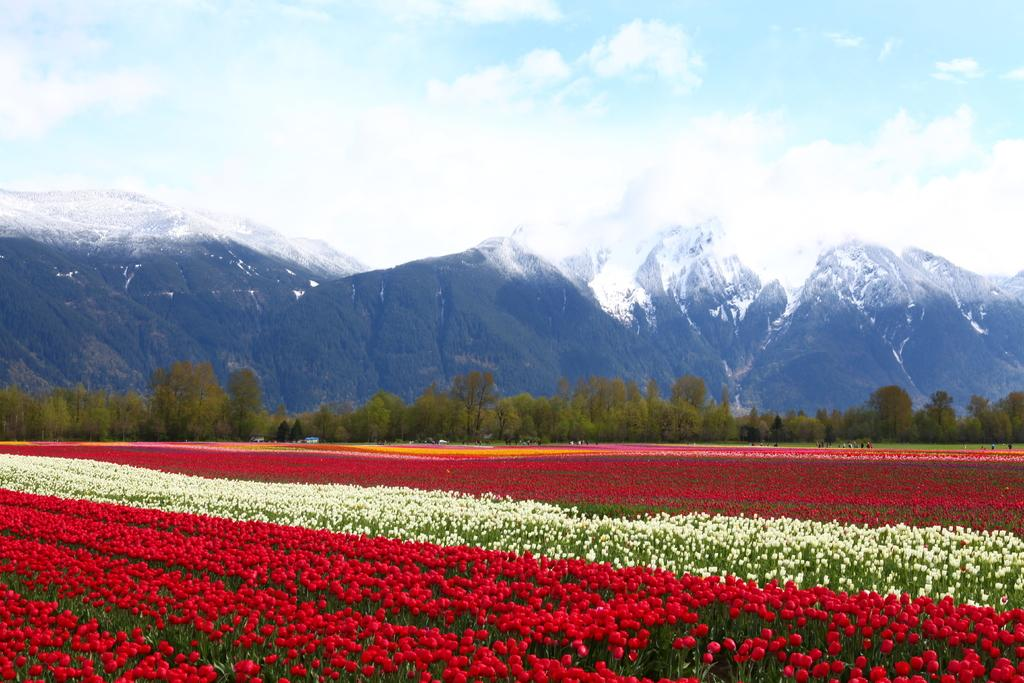What type of plants can be seen in the image? There are plants with flowers in the image. What can be seen in the background of the image? There are trees, mountains, and the sky visible in the background of the image. What is the condition of the sky in the image? Clouds are present in the sky in the image. Can you see any toes sticking out of the flowers in the image? There are no toes present in the image; it features plants with flowers and a background with trees, mountains, and the sky. 